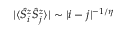<formula> <loc_0><loc_0><loc_500><loc_500>| \langle \hat { S } _ { i } ^ { z } \hat { S } _ { j } ^ { z } \rangle | \sim | i - j | ^ { - 1 / \eta }</formula> 